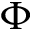<formula> <loc_0><loc_0><loc_500><loc_500>\Phi</formula> 